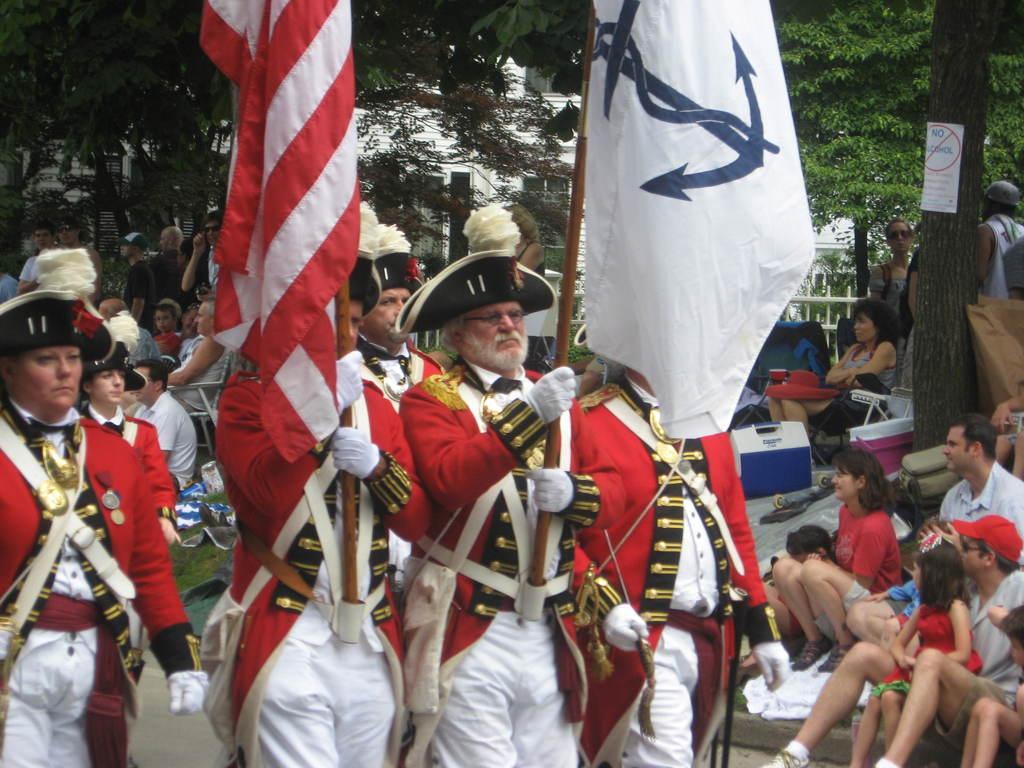In one or two sentences, can you explain what this image depicts? In this image we can see some people holding flags in their hands and we can also see some people sitting, trees and poster with some text. 